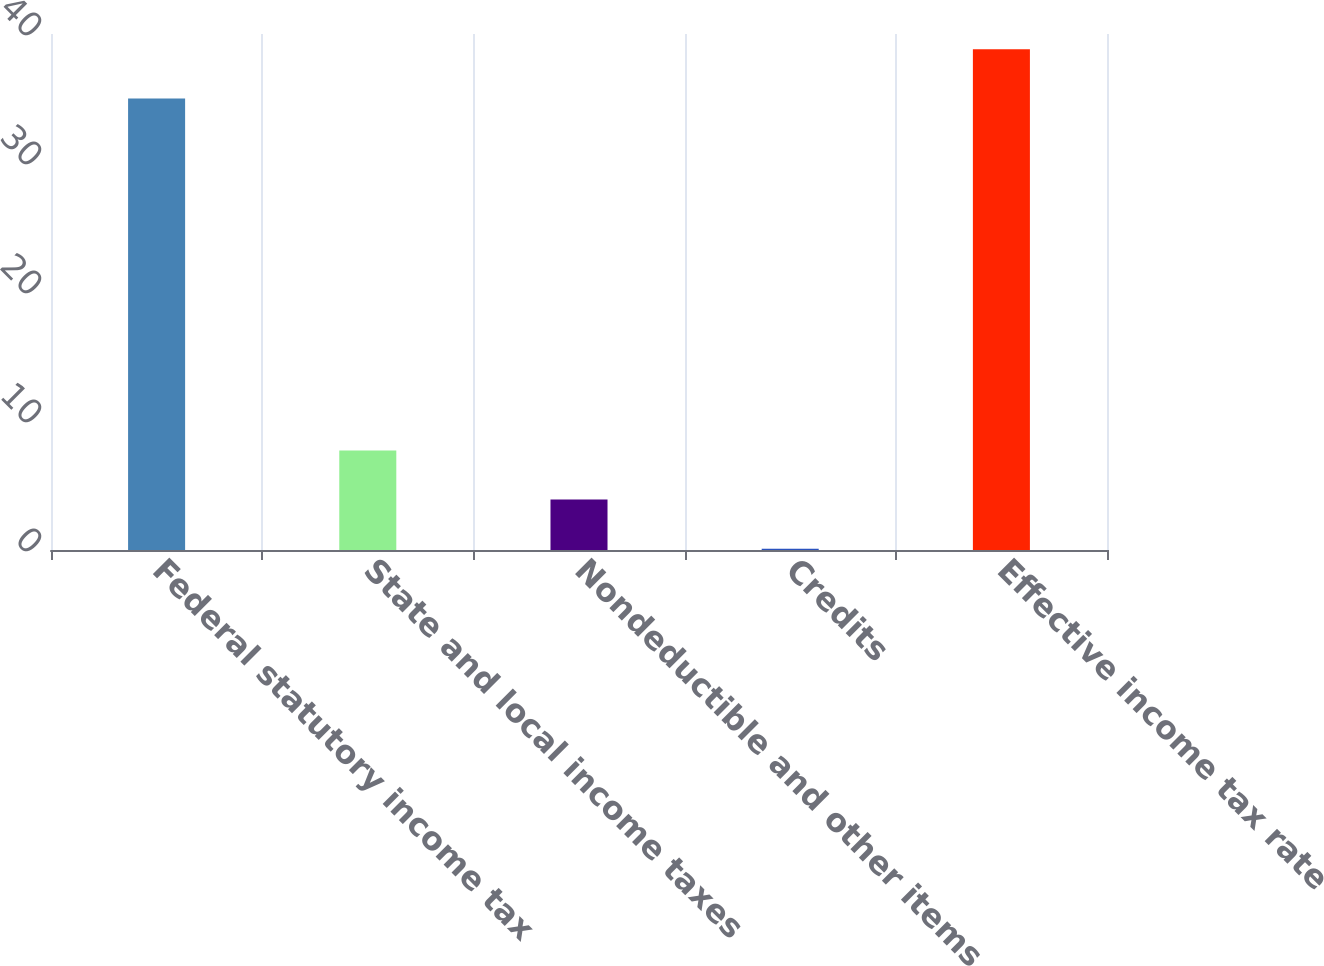<chart> <loc_0><loc_0><loc_500><loc_500><bar_chart><fcel>Federal statutory income tax<fcel>State and local income taxes<fcel>Nondeductible and other items<fcel>Credits<fcel>Effective income tax rate<nl><fcel>35<fcel>7.72<fcel>3.91<fcel>0.1<fcel>38.81<nl></chart> 